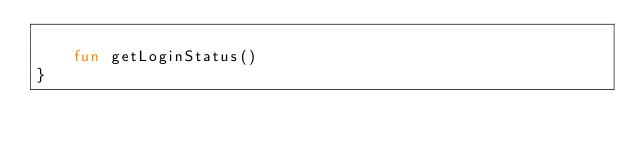Convert code to text. <code><loc_0><loc_0><loc_500><loc_500><_Kotlin_>
    fun getLoginStatus()
}</code> 